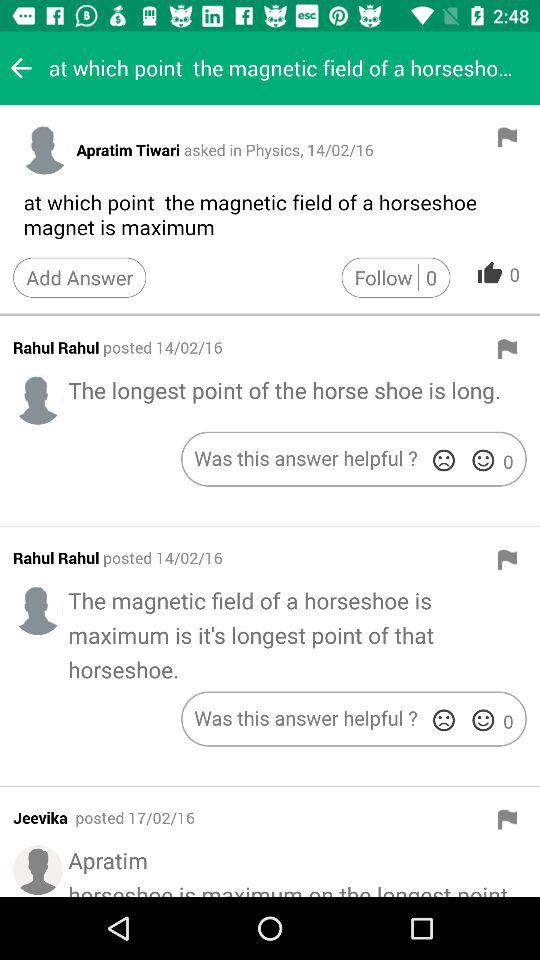Apratim Tiwari asked a question on what subject? Apratim Tiwari has asked a question on "Physics". 